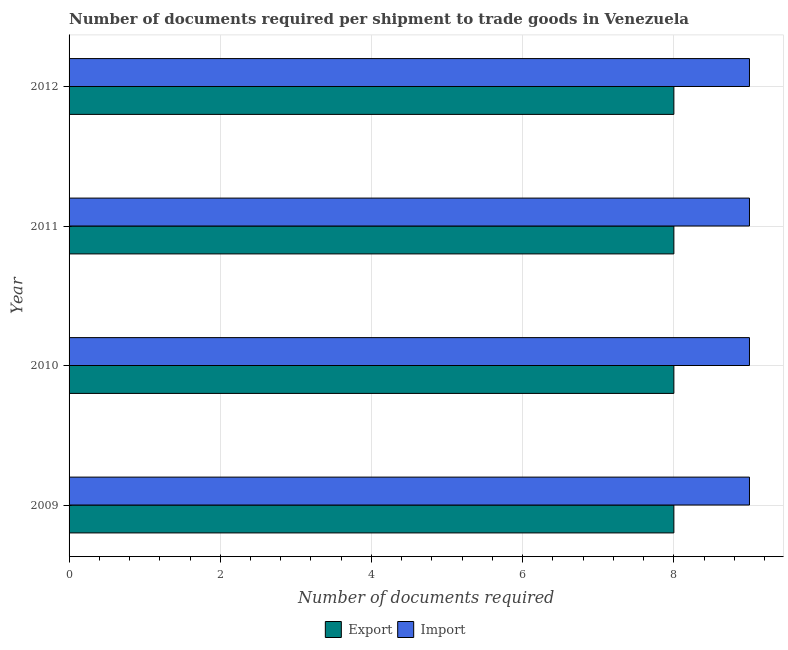How many different coloured bars are there?
Provide a succinct answer. 2. How many groups of bars are there?
Offer a very short reply. 4. Are the number of bars per tick equal to the number of legend labels?
Your response must be concise. Yes. In how many cases, is the number of bars for a given year not equal to the number of legend labels?
Offer a terse response. 0. What is the number of documents required to import goods in 2012?
Ensure brevity in your answer.  9. Across all years, what is the maximum number of documents required to import goods?
Provide a succinct answer. 9. Across all years, what is the minimum number of documents required to import goods?
Provide a short and direct response. 9. In which year was the number of documents required to import goods maximum?
Your answer should be compact. 2009. What is the total number of documents required to export goods in the graph?
Offer a very short reply. 32. What is the difference between the number of documents required to import goods in 2010 and that in 2012?
Provide a short and direct response. 0. What is the difference between the number of documents required to import goods in 2009 and the number of documents required to export goods in 2010?
Make the answer very short. 1. What is the average number of documents required to import goods per year?
Provide a short and direct response. 9. In the year 2011, what is the difference between the number of documents required to import goods and number of documents required to export goods?
Make the answer very short. 1. In how many years, is the number of documents required to export goods greater than 8.4 ?
Your answer should be very brief. 0. What is the difference between the highest and the second highest number of documents required to import goods?
Your response must be concise. 0. What is the difference between the highest and the lowest number of documents required to export goods?
Keep it short and to the point. 0. Is the sum of the number of documents required to export goods in 2010 and 2011 greater than the maximum number of documents required to import goods across all years?
Provide a short and direct response. Yes. What does the 2nd bar from the top in 2010 represents?
Make the answer very short. Export. What does the 1st bar from the bottom in 2009 represents?
Ensure brevity in your answer.  Export. How many bars are there?
Your answer should be compact. 8. Are all the bars in the graph horizontal?
Your answer should be compact. Yes. How many years are there in the graph?
Ensure brevity in your answer.  4. What is the difference between two consecutive major ticks on the X-axis?
Provide a short and direct response. 2. Are the values on the major ticks of X-axis written in scientific E-notation?
Ensure brevity in your answer.  No. Does the graph contain grids?
Your answer should be compact. Yes. Where does the legend appear in the graph?
Your answer should be compact. Bottom center. What is the title of the graph?
Ensure brevity in your answer.  Number of documents required per shipment to trade goods in Venezuela. Does "Public credit registry" appear as one of the legend labels in the graph?
Ensure brevity in your answer.  No. What is the label or title of the X-axis?
Offer a terse response. Number of documents required. What is the Number of documents required in Export in 2009?
Your answer should be compact. 8. What is the Number of documents required of Import in 2009?
Make the answer very short. 9. What is the Number of documents required of Export in 2011?
Offer a terse response. 8. What is the Number of documents required of Import in 2011?
Your answer should be compact. 9. What is the Number of documents required of Export in 2012?
Offer a very short reply. 8. Across all years, what is the maximum Number of documents required in Import?
Your response must be concise. 9. Across all years, what is the minimum Number of documents required of Import?
Offer a terse response. 9. What is the total Number of documents required in Export in the graph?
Your response must be concise. 32. What is the total Number of documents required of Import in the graph?
Give a very brief answer. 36. What is the difference between the Number of documents required of Import in 2009 and that in 2010?
Provide a succinct answer. 0. What is the difference between the Number of documents required of Import in 2009 and that in 2011?
Make the answer very short. 0. What is the difference between the Number of documents required in Export in 2009 and that in 2012?
Provide a succinct answer. 0. What is the difference between the Number of documents required of Export in 2010 and that in 2012?
Make the answer very short. 0. What is the difference between the Number of documents required of Export in 2011 and that in 2012?
Your answer should be very brief. 0. What is the difference between the Number of documents required in Import in 2011 and that in 2012?
Your response must be concise. 0. What is the difference between the Number of documents required of Export in 2009 and the Number of documents required of Import in 2011?
Provide a short and direct response. -1. What is the difference between the Number of documents required in Export in 2009 and the Number of documents required in Import in 2012?
Your response must be concise. -1. What is the difference between the Number of documents required in Export in 2010 and the Number of documents required in Import in 2012?
Keep it short and to the point. -1. What is the difference between the Number of documents required of Export in 2011 and the Number of documents required of Import in 2012?
Provide a succinct answer. -1. What is the average Number of documents required in Export per year?
Ensure brevity in your answer.  8. In the year 2009, what is the difference between the Number of documents required in Export and Number of documents required in Import?
Provide a short and direct response. -1. In the year 2010, what is the difference between the Number of documents required of Export and Number of documents required of Import?
Your answer should be very brief. -1. In the year 2012, what is the difference between the Number of documents required in Export and Number of documents required in Import?
Your answer should be compact. -1. What is the ratio of the Number of documents required in Import in 2009 to that in 2010?
Provide a short and direct response. 1. What is the ratio of the Number of documents required in Export in 2009 to that in 2012?
Keep it short and to the point. 1. What is the ratio of the Number of documents required of Export in 2010 to that in 2011?
Make the answer very short. 1. What is the ratio of the Number of documents required of Import in 2010 to that in 2011?
Keep it short and to the point. 1. What is the ratio of the Number of documents required in Export in 2010 to that in 2012?
Offer a very short reply. 1. What is the ratio of the Number of documents required of Import in 2010 to that in 2012?
Your answer should be very brief. 1. What is the ratio of the Number of documents required in Import in 2011 to that in 2012?
Keep it short and to the point. 1. What is the difference between the highest and the lowest Number of documents required of Export?
Provide a short and direct response. 0. What is the difference between the highest and the lowest Number of documents required in Import?
Your response must be concise. 0. 